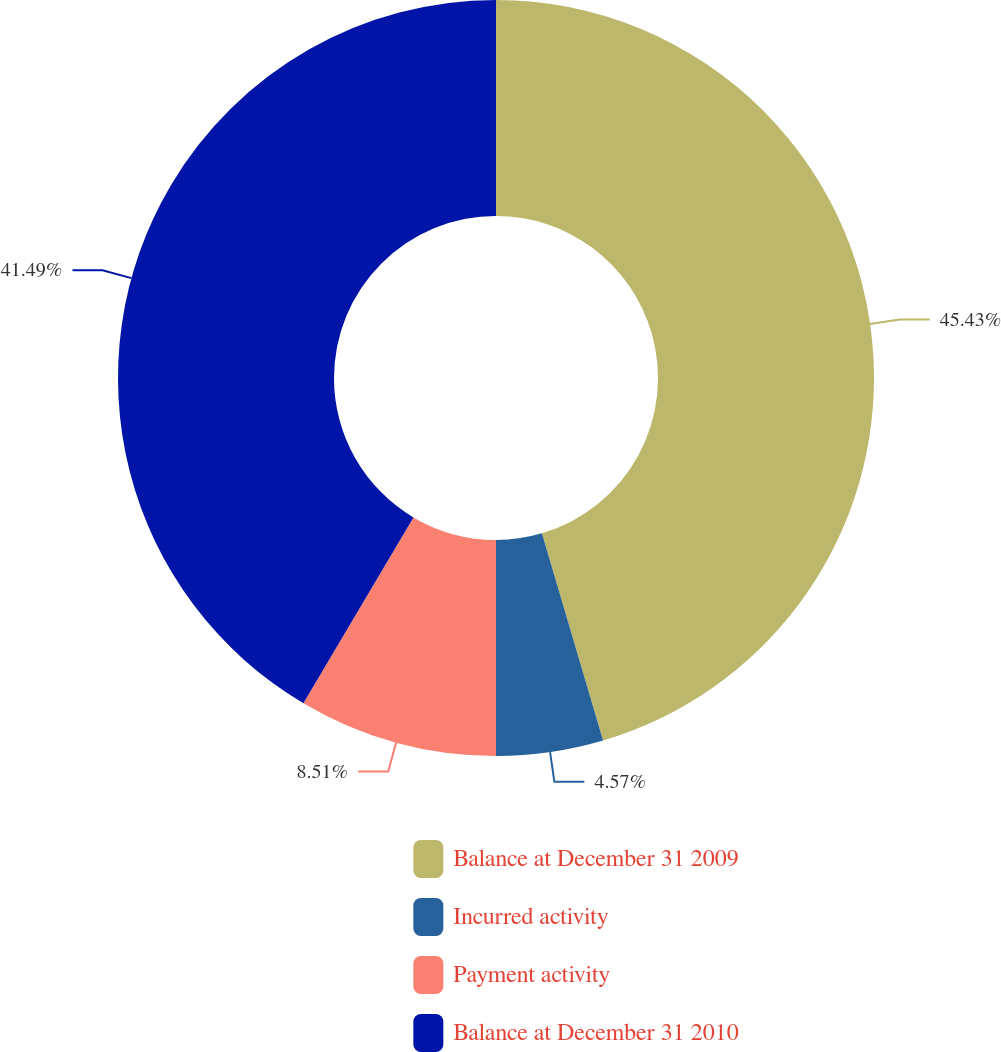Convert chart. <chart><loc_0><loc_0><loc_500><loc_500><pie_chart><fcel>Balance at December 31 2009<fcel>Incurred activity<fcel>Payment activity<fcel>Balance at December 31 2010<nl><fcel>45.43%<fcel>4.57%<fcel>8.51%<fcel>41.49%<nl></chart> 